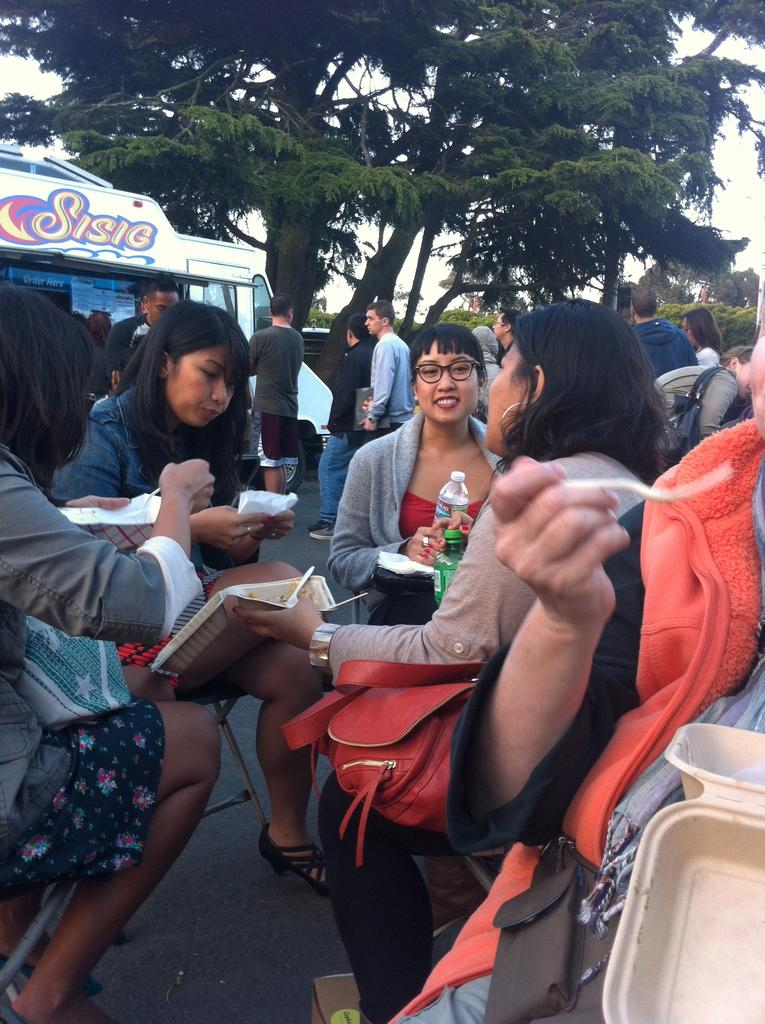What are the people in the image doing? The people in the image are sitting on chairs. What object can be seen besides the people and chairs? There is a bottle visible in the image. What type of items are present on the chairs or nearby? There are papers in the image. What can be seen in the background of the image? There are trees and the sky visible in the image. What type of copper material is present in the image? There is no copper material present in the image. How many babies can be seen in the image? There are no babies present in the image. 